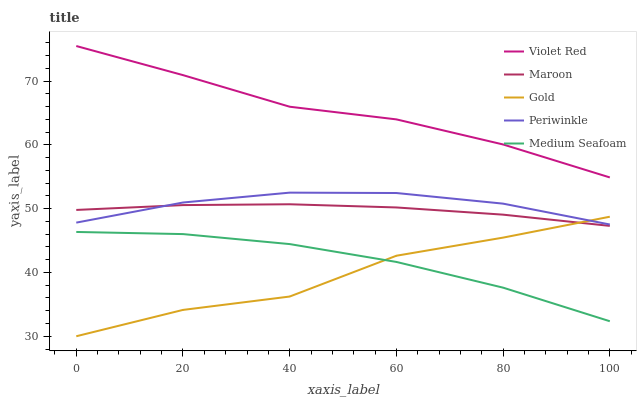Does Periwinkle have the minimum area under the curve?
Answer yes or no. No. Does Periwinkle have the maximum area under the curve?
Answer yes or no. No. Is Periwinkle the smoothest?
Answer yes or no. No. Is Periwinkle the roughest?
Answer yes or no. No. Does Periwinkle have the lowest value?
Answer yes or no. No. Does Periwinkle have the highest value?
Answer yes or no. No. Is Medium Seafoam less than Maroon?
Answer yes or no. Yes. Is Violet Red greater than Medium Seafoam?
Answer yes or no. Yes. Does Medium Seafoam intersect Maroon?
Answer yes or no. No. 